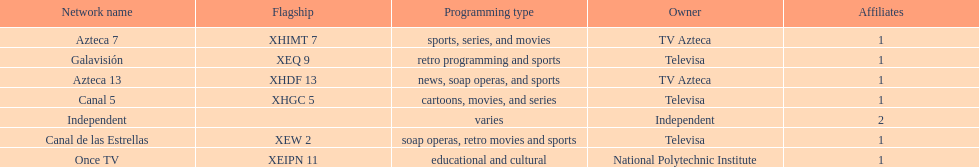What is the only network owned by national polytechnic institute? Once TV. 